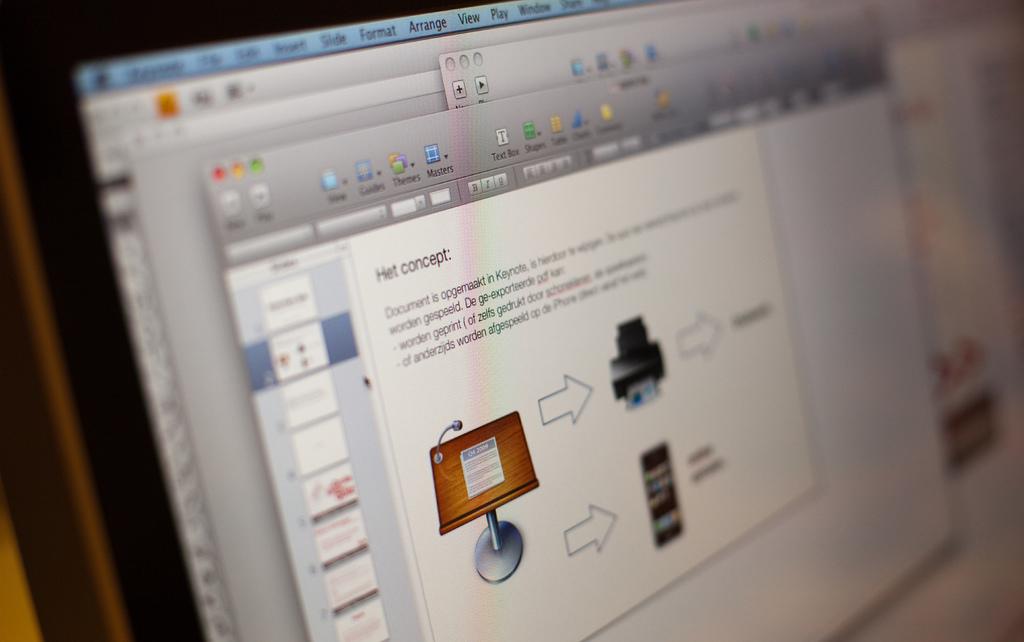What is the title of this section?
Your answer should be very brief. Het concept. 